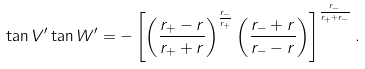Convert formula to latex. <formula><loc_0><loc_0><loc_500><loc_500>\tan V ^ { \prime } \tan W ^ { \prime } = - \left [ \left ( \frac { r _ { + } - r } { r _ { + } + r } \right ) ^ { \frac { r _ { - } } { r _ { + } } } \left ( \frac { r _ { - } + r } { r _ { - } - r } \right ) \right ] ^ { \frac { r _ { - } } { r _ { + } + r _ { - } } } .</formula> 